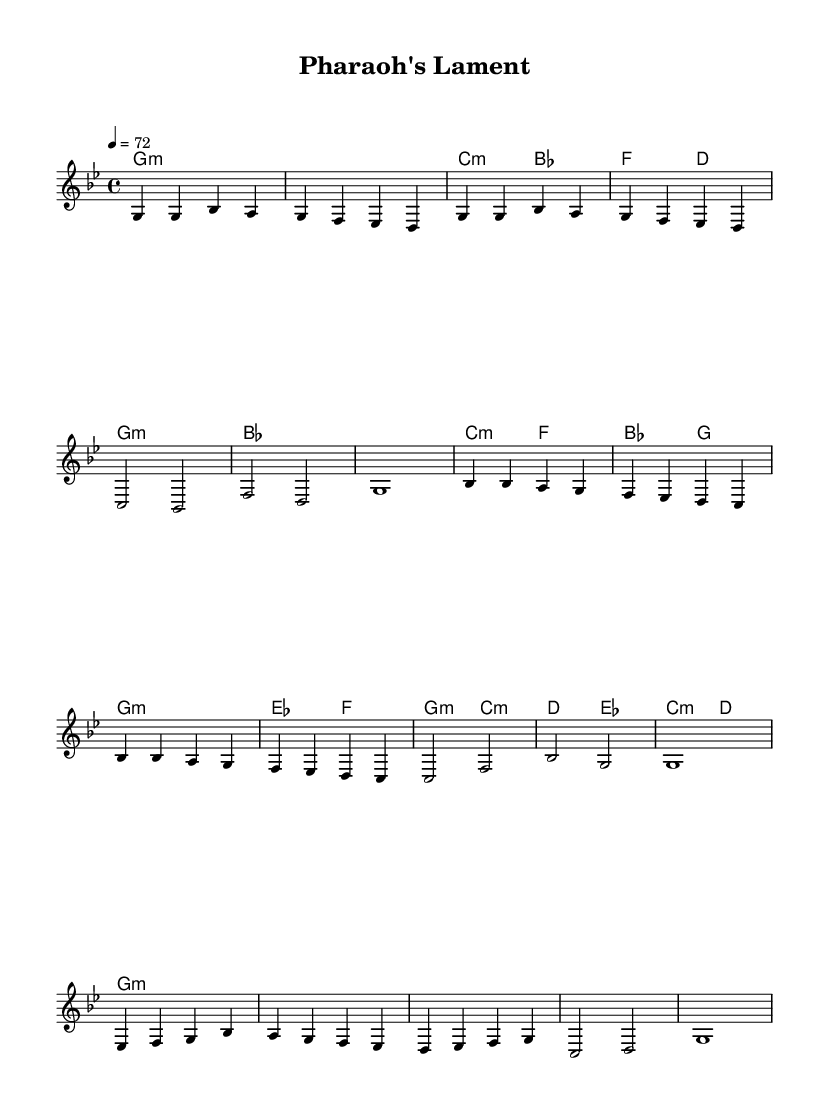what is the key signature of this music? The key signature is indicated at the beginning of the score. It shows two flats, which corresponds to G minor.
Answer: G minor what is the time signature of this music? The time signature is found at the beginning of the score. It is displayed as 4/4, which indicates four beats per measure.
Answer: 4/4 what is the tempo of this piece? The tempo marking is shown above the staff and is recorded as "4 = 72." This means that the quarter note is set to 72 beats per minute.
Answer: 72 how many measures are in the verse section? By counting the measures in the melody section labeled as "Verse," there are a total of 8 measures.
Answer: 8 which chords are used in the chorus? The chorus section contains chords listed under "ChordNames." The chords shown for the chorus are B flat major, C minor, and F major.
Answer: B flat major, C minor, F major what is the structure of the composition? The structure is inferred from the layout of the music: it has a Verse, Chorus, and Bridge indicating a common song structure often used in Country music.
Answer: Verse, Chorus, Bridge how does this piece reflect country ballad characteristics? The slower tempo, storytelling nature in lyrics suggested by the section names, and the use of traditional harmonies are hallmarks of Country ballads.
Answer: Storytelling, slow tempo, traditional harmonies 